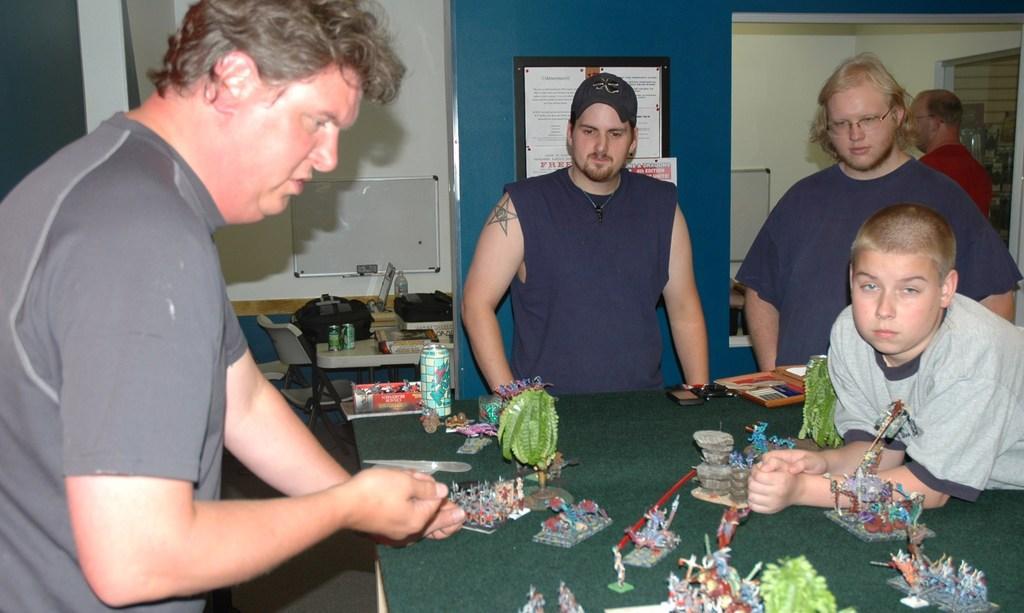Can you describe this image briefly? On the background we can see wall, white board and frames. here on the table we can see mini miniatures, tins and bags. we can see all the persons standing here. 